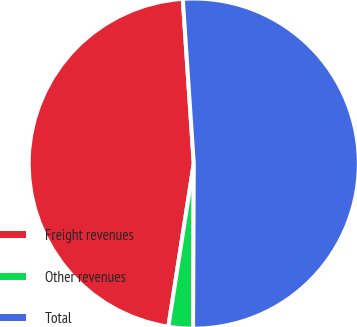Convert chart to OTSL. <chart><loc_0><loc_0><loc_500><loc_500><pie_chart><fcel>Freight revenues<fcel>Other revenues<fcel>Total<nl><fcel>46.48%<fcel>2.39%<fcel>51.13%<nl></chart> 